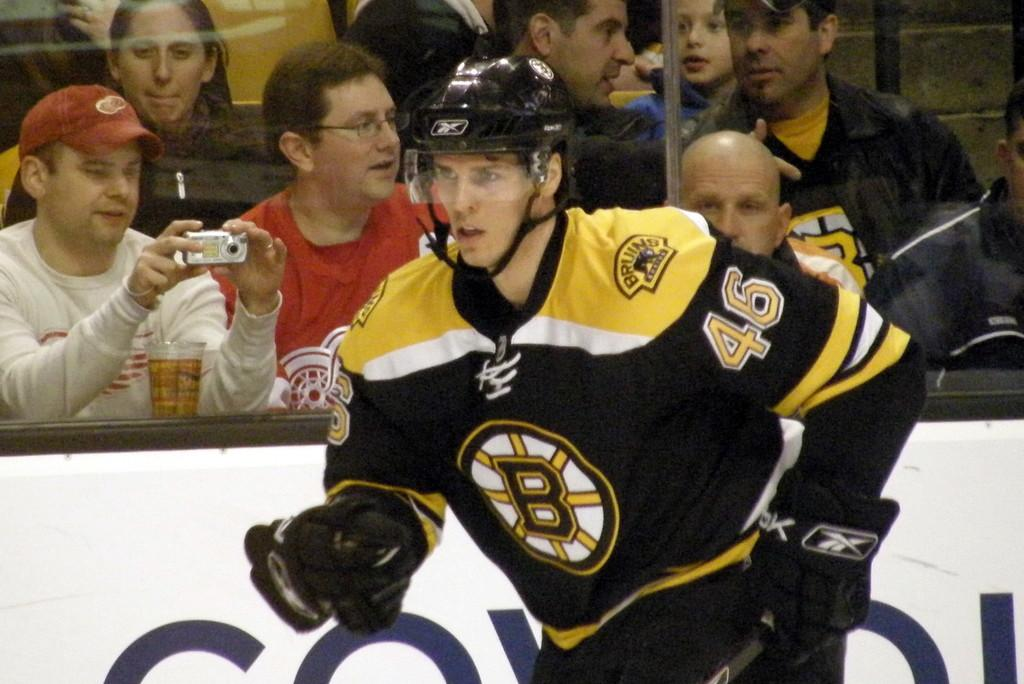What is the main subject in the foreground of the image? There is a person in the foreground of the image. What is the person wearing? The person is wearing a helmet. What can be seen in the background of the image? People are visible through the glass in the background of the image. What is the purpose of the fencing in the image? The fencing has text on it, which suggests it may be used for displaying information or advertisements. Can you see any fangs in the image? There are no fangs present in the image. What role does the lead play in the image? There is no mention of a lead in the image, so its role cannot be determined. 